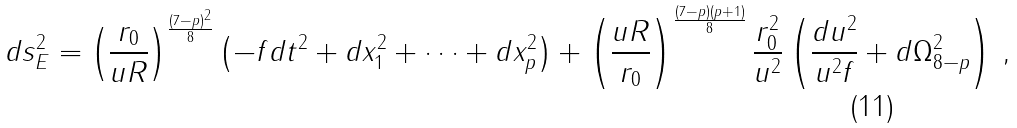Convert formula to latex. <formula><loc_0><loc_0><loc_500><loc_500>d s ^ { 2 } _ { E } = \left ( \frac { r _ { 0 } } { u R } \right ) ^ { \frac { ( 7 - p ) ^ { 2 } } 8 } \left ( - f d t ^ { 2 } + d x _ { 1 } ^ { 2 } + \cdots + d x _ { p } ^ { 2 } \right ) + \left ( \frac { u R } { r _ { 0 } } \right ) ^ { \frac { ( 7 - p ) ( p + 1 ) } 8 } \frac { r _ { 0 } ^ { 2 } } { u ^ { 2 } } \left ( \frac { d u ^ { 2 } } { u ^ { 2 } f } + d \Omega ^ { 2 } _ { 8 - p } \right ) \, ,</formula> 